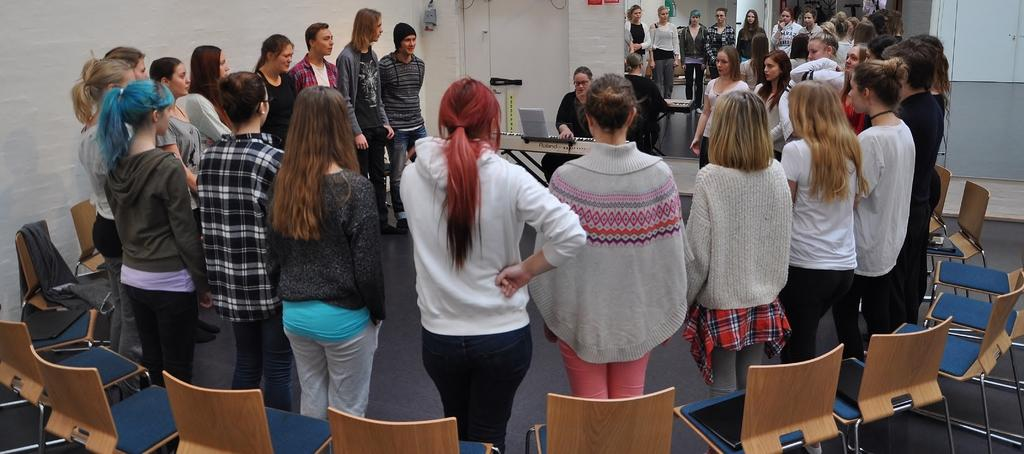What is the main subject of the image? There is a person in the image. What is the person wearing? The person is wearing a black dress. What is the person doing in the image? The person is playing a piano. Can you describe the people surrounding the person playing the piano? There is a group of people around the person playing the piano. How many pizzas are being served to the toad in the image? There is no toad or pizzas present in the image. 